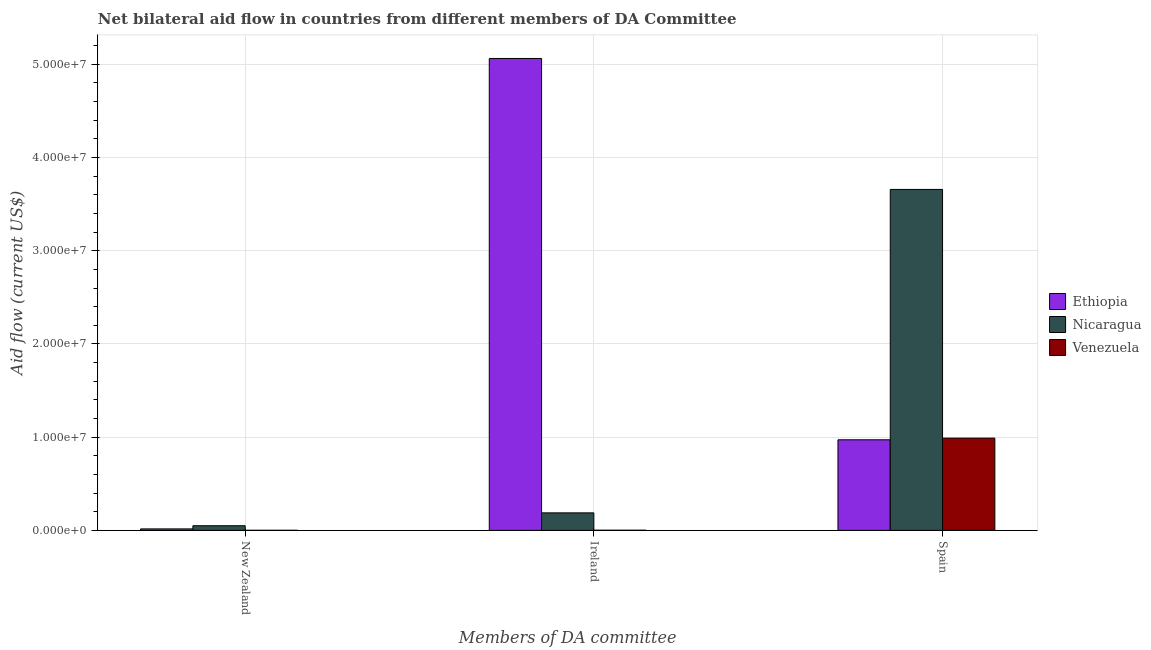Are the number of bars on each tick of the X-axis equal?
Your answer should be very brief. Yes. How many bars are there on the 2nd tick from the right?
Provide a succinct answer. 3. What is the label of the 2nd group of bars from the left?
Keep it short and to the point. Ireland. What is the amount of aid provided by ireland in Ethiopia?
Your answer should be very brief. 5.06e+07. Across all countries, what is the maximum amount of aid provided by spain?
Give a very brief answer. 3.66e+07. Across all countries, what is the minimum amount of aid provided by spain?
Give a very brief answer. 9.72e+06. In which country was the amount of aid provided by new zealand maximum?
Your answer should be very brief. Nicaragua. In which country was the amount of aid provided by new zealand minimum?
Offer a very short reply. Venezuela. What is the total amount of aid provided by spain in the graph?
Offer a terse response. 5.62e+07. What is the difference between the amount of aid provided by ireland in Nicaragua and that in Ethiopia?
Your answer should be compact. -4.88e+07. What is the difference between the amount of aid provided by spain in Ethiopia and the amount of aid provided by new zealand in Nicaragua?
Keep it short and to the point. 9.22e+06. What is the average amount of aid provided by ireland per country?
Provide a succinct answer. 1.75e+07. What is the difference between the amount of aid provided by spain and amount of aid provided by new zealand in Ethiopia?
Keep it short and to the point. 9.56e+06. Is the amount of aid provided by ireland in Nicaragua less than that in Ethiopia?
Keep it short and to the point. Yes. Is the difference between the amount of aid provided by ireland in Nicaragua and Ethiopia greater than the difference between the amount of aid provided by new zealand in Nicaragua and Ethiopia?
Your response must be concise. No. What is the difference between the highest and the second highest amount of aid provided by new zealand?
Offer a very short reply. 3.40e+05. What is the difference between the highest and the lowest amount of aid provided by spain?
Ensure brevity in your answer.  2.69e+07. Is the sum of the amount of aid provided by new zealand in Nicaragua and Venezuela greater than the maximum amount of aid provided by ireland across all countries?
Keep it short and to the point. No. What does the 1st bar from the left in Spain represents?
Provide a succinct answer. Ethiopia. What does the 2nd bar from the right in New Zealand represents?
Give a very brief answer. Nicaragua. How many bars are there?
Make the answer very short. 9. Are all the bars in the graph horizontal?
Make the answer very short. No. Are the values on the major ticks of Y-axis written in scientific E-notation?
Your answer should be very brief. Yes. Does the graph contain any zero values?
Your answer should be compact. No. Where does the legend appear in the graph?
Your response must be concise. Center right. How are the legend labels stacked?
Ensure brevity in your answer.  Vertical. What is the title of the graph?
Your response must be concise. Net bilateral aid flow in countries from different members of DA Committee. Does "Bosnia and Herzegovina" appear as one of the legend labels in the graph?
Your answer should be very brief. No. What is the label or title of the X-axis?
Your answer should be compact. Members of DA committee. What is the label or title of the Y-axis?
Ensure brevity in your answer.  Aid flow (current US$). What is the Aid flow (current US$) of Ethiopia in New Zealand?
Your response must be concise. 1.60e+05. What is the Aid flow (current US$) of Nicaragua in New Zealand?
Your answer should be very brief. 5.00e+05. What is the Aid flow (current US$) in Ethiopia in Ireland?
Keep it short and to the point. 5.06e+07. What is the Aid flow (current US$) of Nicaragua in Ireland?
Make the answer very short. 1.88e+06. What is the Aid flow (current US$) in Ethiopia in Spain?
Your answer should be very brief. 9.72e+06. What is the Aid flow (current US$) of Nicaragua in Spain?
Make the answer very short. 3.66e+07. What is the Aid flow (current US$) of Venezuela in Spain?
Provide a short and direct response. 9.90e+06. Across all Members of DA committee, what is the maximum Aid flow (current US$) of Ethiopia?
Provide a succinct answer. 5.06e+07. Across all Members of DA committee, what is the maximum Aid flow (current US$) in Nicaragua?
Make the answer very short. 3.66e+07. Across all Members of DA committee, what is the maximum Aid flow (current US$) in Venezuela?
Offer a terse response. 9.90e+06. What is the total Aid flow (current US$) of Ethiopia in the graph?
Your answer should be compact. 6.05e+07. What is the total Aid flow (current US$) of Nicaragua in the graph?
Your response must be concise. 3.90e+07. What is the total Aid flow (current US$) in Venezuela in the graph?
Provide a short and direct response. 9.93e+06. What is the difference between the Aid flow (current US$) of Ethiopia in New Zealand and that in Ireland?
Provide a short and direct response. -5.05e+07. What is the difference between the Aid flow (current US$) of Nicaragua in New Zealand and that in Ireland?
Provide a short and direct response. -1.38e+06. What is the difference between the Aid flow (current US$) of Ethiopia in New Zealand and that in Spain?
Provide a short and direct response. -9.56e+06. What is the difference between the Aid flow (current US$) of Nicaragua in New Zealand and that in Spain?
Your answer should be very brief. -3.61e+07. What is the difference between the Aid flow (current US$) in Venezuela in New Zealand and that in Spain?
Give a very brief answer. -9.89e+06. What is the difference between the Aid flow (current US$) of Ethiopia in Ireland and that in Spain?
Provide a short and direct response. 4.09e+07. What is the difference between the Aid flow (current US$) in Nicaragua in Ireland and that in Spain?
Your answer should be compact. -3.47e+07. What is the difference between the Aid flow (current US$) of Venezuela in Ireland and that in Spain?
Ensure brevity in your answer.  -9.88e+06. What is the difference between the Aid flow (current US$) in Ethiopia in New Zealand and the Aid flow (current US$) in Nicaragua in Ireland?
Provide a short and direct response. -1.72e+06. What is the difference between the Aid flow (current US$) in Ethiopia in New Zealand and the Aid flow (current US$) in Venezuela in Ireland?
Your answer should be compact. 1.40e+05. What is the difference between the Aid flow (current US$) of Ethiopia in New Zealand and the Aid flow (current US$) of Nicaragua in Spain?
Your response must be concise. -3.64e+07. What is the difference between the Aid flow (current US$) of Ethiopia in New Zealand and the Aid flow (current US$) of Venezuela in Spain?
Keep it short and to the point. -9.74e+06. What is the difference between the Aid flow (current US$) in Nicaragua in New Zealand and the Aid flow (current US$) in Venezuela in Spain?
Your answer should be compact. -9.40e+06. What is the difference between the Aid flow (current US$) in Ethiopia in Ireland and the Aid flow (current US$) in Nicaragua in Spain?
Make the answer very short. 1.40e+07. What is the difference between the Aid flow (current US$) of Ethiopia in Ireland and the Aid flow (current US$) of Venezuela in Spain?
Provide a succinct answer. 4.07e+07. What is the difference between the Aid flow (current US$) of Nicaragua in Ireland and the Aid flow (current US$) of Venezuela in Spain?
Keep it short and to the point. -8.02e+06. What is the average Aid flow (current US$) of Ethiopia per Members of DA committee?
Your answer should be very brief. 2.02e+07. What is the average Aid flow (current US$) in Nicaragua per Members of DA committee?
Provide a short and direct response. 1.30e+07. What is the average Aid flow (current US$) of Venezuela per Members of DA committee?
Your answer should be compact. 3.31e+06. What is the difference between the Aid flow (current US$) in Ethiopia and Aid flow (current US$) in Venezuela in New Zealand?
Keep it short and to the point. 1.50e+05. What is the difference between the Aid flow (current US$) of Ethiopia and Aid flow (current US$) of Nicaragua in Ireland?
Give a very brief answer. 4.88e+07. What is the difference between the Aid flow (current US$) of Ethiopia and Aid flow (current US$) of Venezuela in Ireland?
Offer a terse response. 5.06e+07. What is the difference between the Aid flow (current US$) in Nicaragua and Aid flow (current US$) in Venezuela in Ireland?
Offer a terse response. 1.86e+06. What is the difference between the Aid flow (current US$) of Ethiopia and Aid flow (current US$) of Nicaragua in Spain?
Offer a very short reply. -2.69e+07. What is the difference between the Aid flow (current US$) in Ethiopia and Aid flow (current US$) in Venezuela in Spain?
Provide a succinct answer. -1.80e+05. What is the difference between the Aid flow (current US$) in Nicaragua and Aid flow (current US$) in Venezuela in Spain?
Ensure brevity in your answer.  2.67e+07. What is the ratio of the Aid flow (current US$) of Ethiopia in New Zealand to that in Ireland?
Provide a succinct answer. 0. What is the ratio of the Aid flow (current US$) of Nicaragua in New Zealand to that in Ireland?
Your answer should be compact. 0.27. What is the ratio of the Aid flow (current US$) in Venezuela in New Zealand to that in Ireland?
Ensure brevity in your answer.  0.5. What is the ratio of the Aid flow (current US$) of Ethiopia in New Zealand to that in Spain?
Keep it short and to the point. 0.02. What is the ratio of the Aid flow (current US$) of Nicaragua in New Zealand to that in Spain?
Offer a very short reply. 0.01. What is the ratio of the Aid flow (current US$) of Ethiopia in Ireland to that in Spain?
Keep it short and to the point. 5.21. What is the ratio of the Aid flow (current US$) of Nicaragua in Ireland to that in Spain?
Your answer should be compact. 0.05. What is the ratio of the Aid flow (current US$) of Venezuela in Ireland to that in Spain?
Your response must be concise. 0. What is the difference between the highest and the second highest Aid flow (current US$) of Ethiopia?
Make the answer very short. 4.09e+07. What is the difference between the highest and the second highest Aid flow (current US$) of Nicaragua?
Offer a very short reply. 3.47e+07. What is the difference between the highest and the second highest Aid flow (current US$) of Venezuela?
Your response must be concise. 9.88e+06. What is the difference between the highest and the lowest Aid flow (current US$) of Ethiopia?
Offer a terse response. 5.05e+07. What is the difference between the highest and the lowest Aid flow (current US$) of Nicaragua?
Make the answer very short. 3.61e+07. What is the difference between the highest and the lowest Aid flow (current US$) in Venezuela?
Provide a succinct answer. 9.89e+06. 